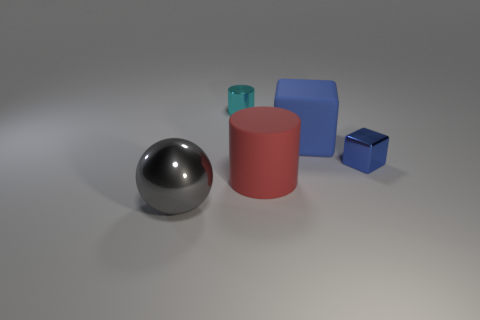Do the metal cube and the large cube have the same color?
Offer a terse response. Yes. Is the color of the block that is on the left side of the tiny blue block the same as the tiny cube?
Ensure brevity in your answer.  Yes. Are there an equal number of metallic spheres on the left side of the big ball and big blue cubes?
Ensure brevity in your answer.  No. Are there any small cubes of the same color as the large cylinder?
Your answer should be very brief. No. Do the shiny ball and the metal block have the same size?
Offer a very short reply. No. How big is the shiny object on the right side of the cylinder left of the big cylinder?
Your answer should be compact. Small. How big is the thing that is behind the metal block and right of the tiny metal cylinder?
Make the answer very short. Large. How many shiny blocks have the same size as the cyan metal thing?
Your answer should be very brief. 1. How many matte things are either big brown spheres or small cyan things?
Your response must be concise. 0. What is the size of the other block that is the same color as the large block?
Provide a succinct answer. Small. 